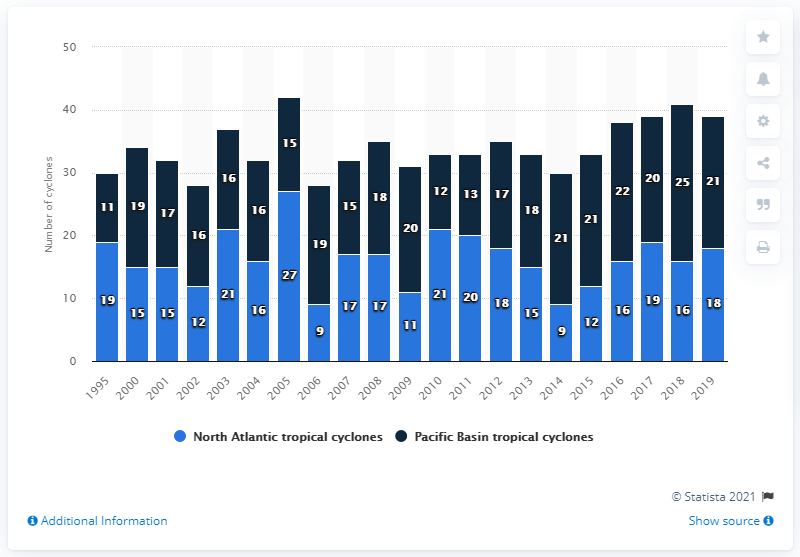Highlight a few significant elements in this photo. In 2019, a total of 18 North Atlantic tropical cyclones made landfall on the United States. 